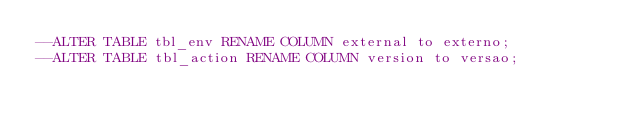Convert code to text. <code><loc_0><loc_0><loc_500><loc_500><_SQL_>--ALTER TABLE tbl_env RENAME COLUMN external to externo;
--ALTER TABLE tbl_action RENAME COLUMN version to versao;</code> 